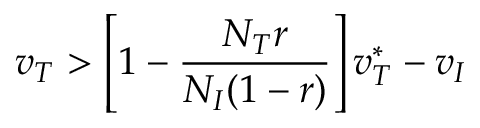Convert formula to latex. <formula><loc_0><loc_0><loc_500><loc_500>v _ { T } > \left [ 1 - \frac { N _ { T } r } { N _ { I } ( 1 - r ) } \right ] v _ { T } ^ { * } - v _ { I }</formula> 